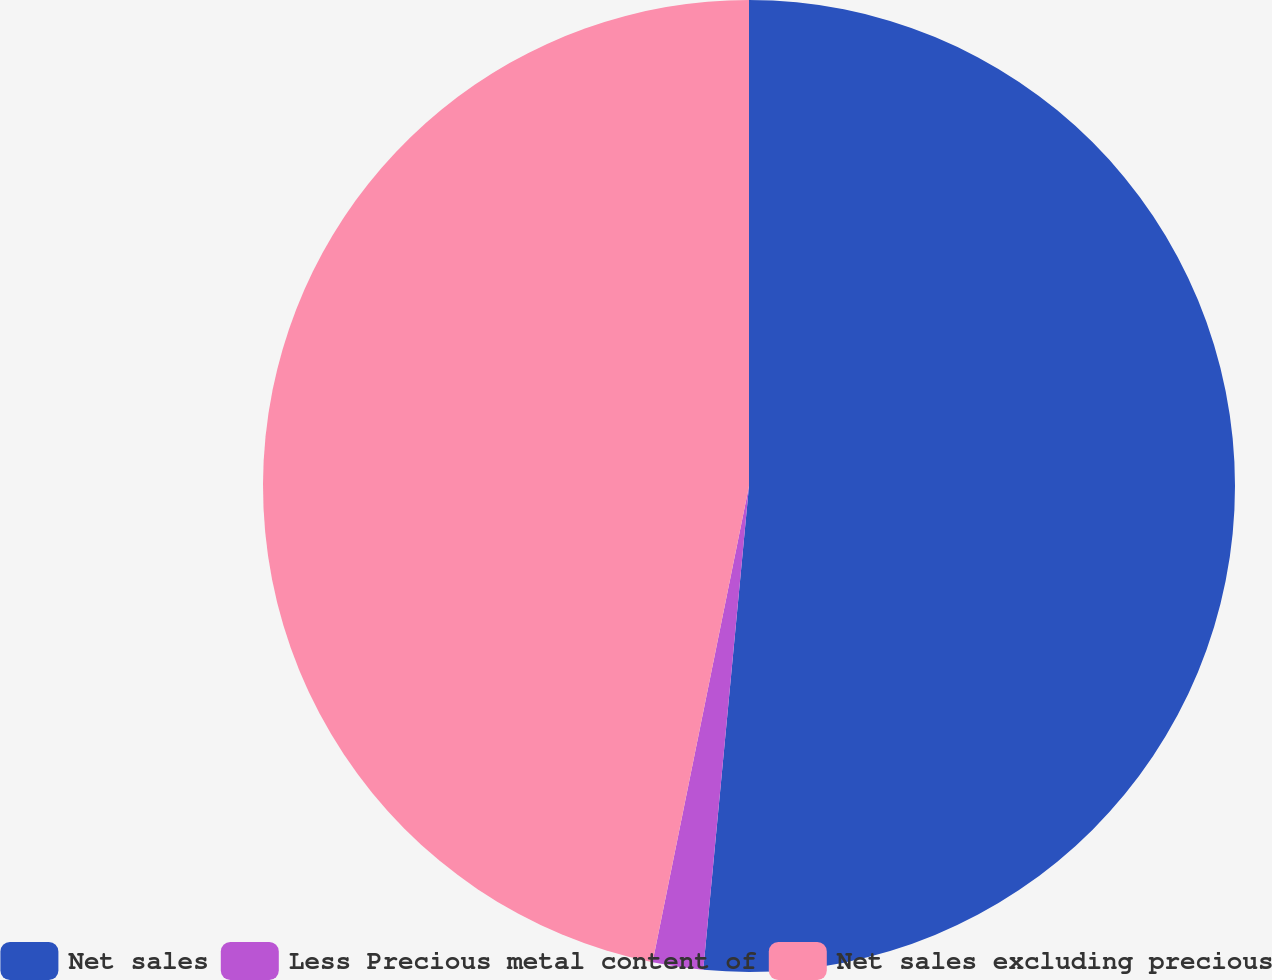Convert chart. <chart><loc_0><loc_0><loc_500><loc_500><pie_chart><fcel>Net sales<fcel>Less Precious metal content of<fcel>Net sales excluding precious<nl><fcel>51.5%<fcel>1.68%<fcel>46.82%<nl></chart> 